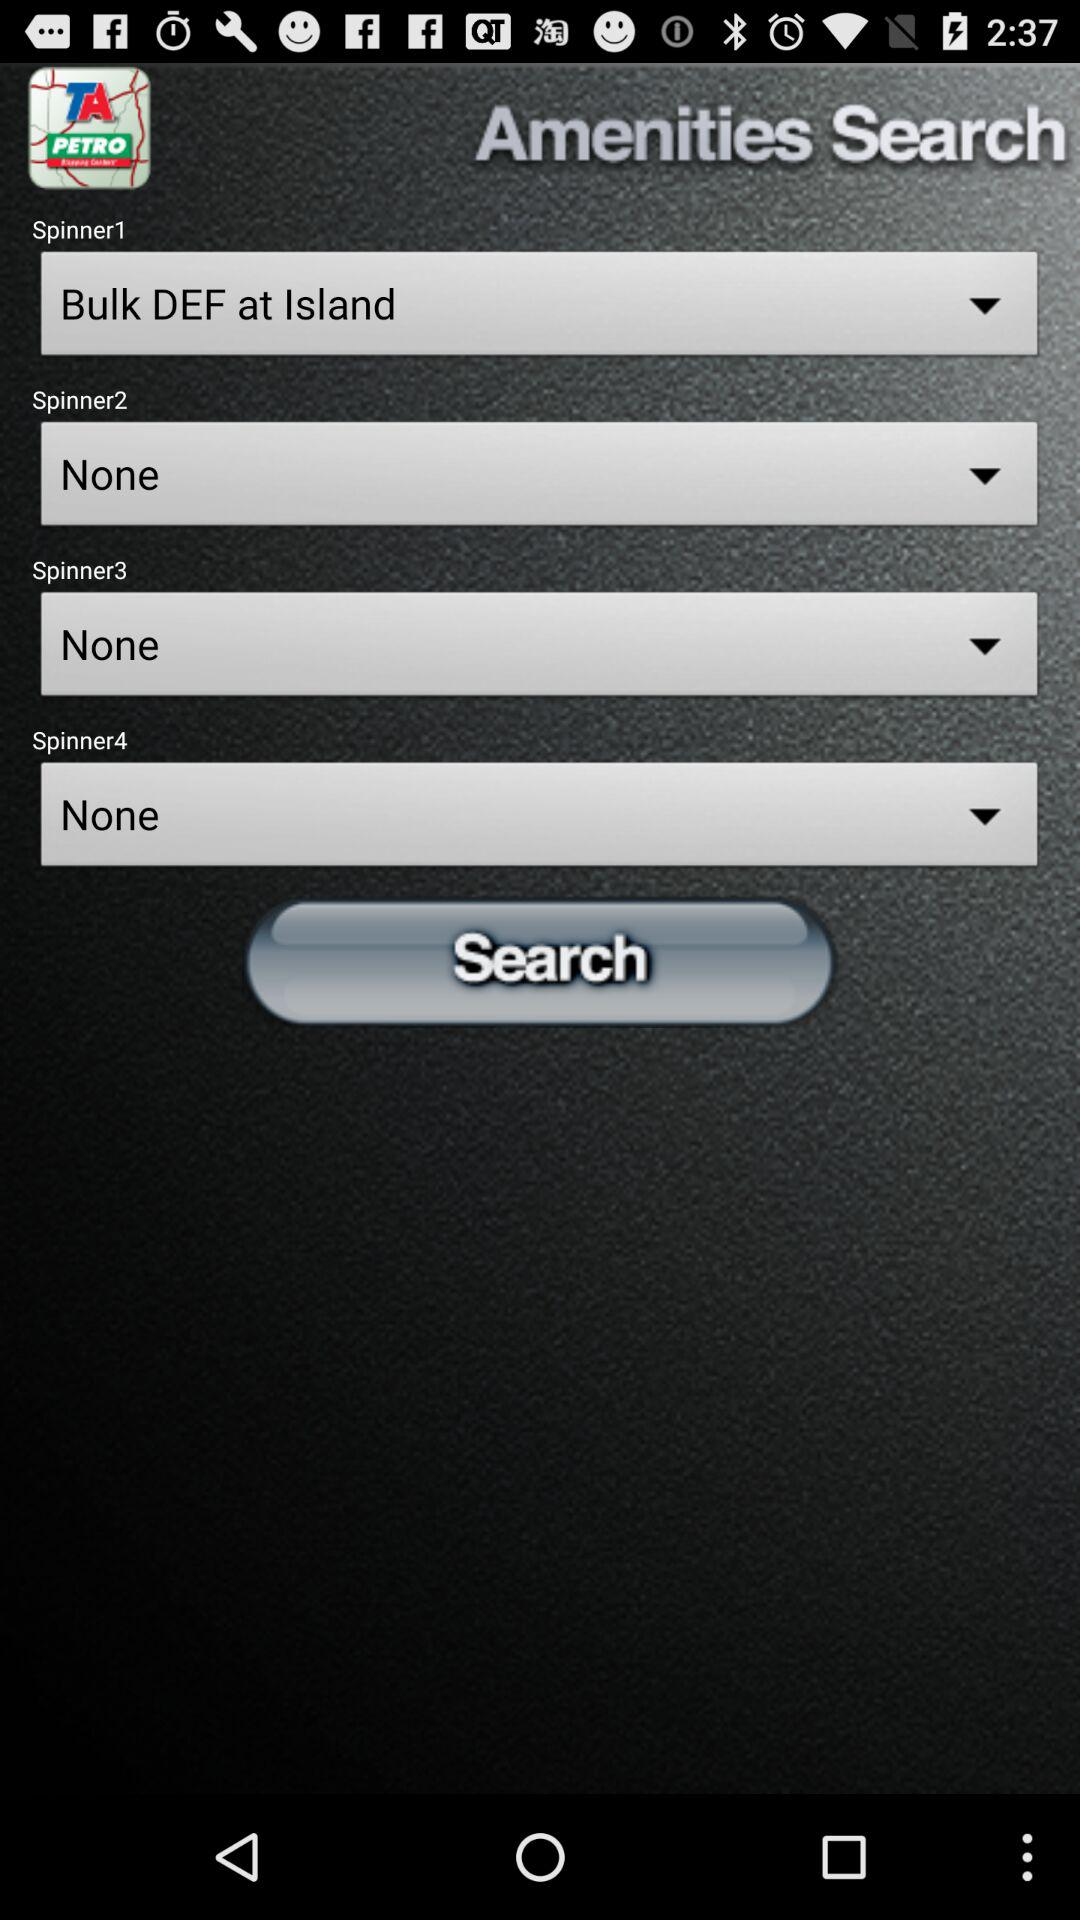Which option is selected for "Spinner1"? The selected option for "Spinner1" is "Bulk DEF at Island". 